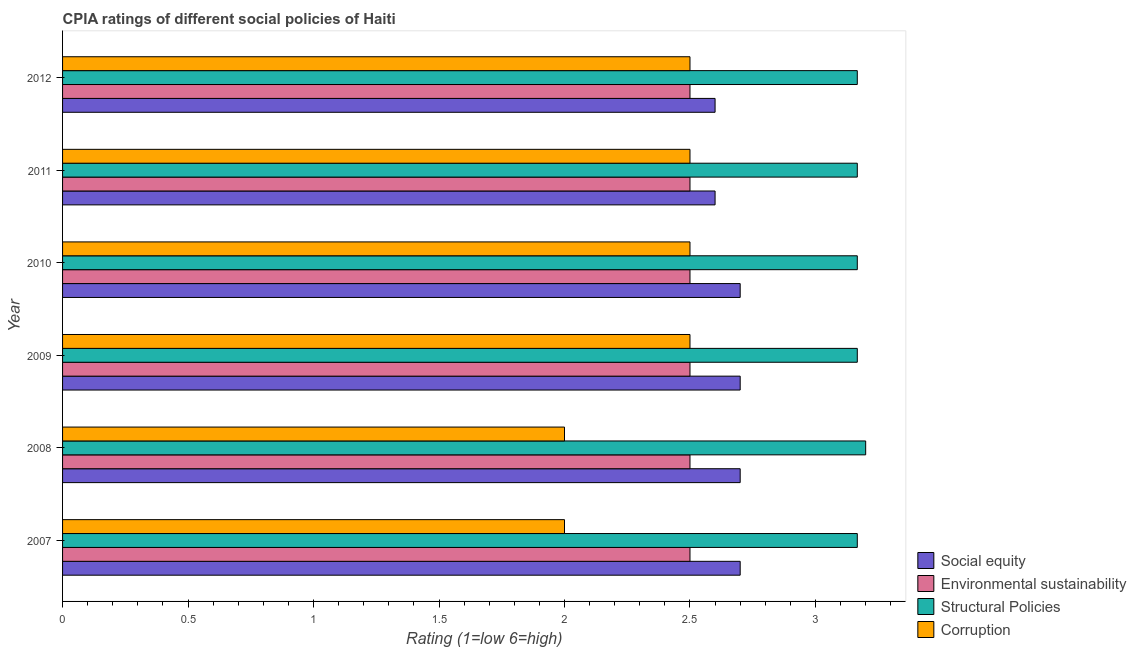Are the number of bars per tick equal to the number of legend labels?
Offer a terse response. Yes. Are the number of bars on each tick of the Y-axis equal?
Offer a very short reply. Yes. How many bars are there on the 2nd tick from the top?
Your answer should be very brief. 4. What is the label of the 5th group of bars from the top?
Offer a very short reply. 2008. Across all years, what is the maximum cpia rating of environmental sustainability?
Provide a succinct answer. 2.5. What is the difference between the cpia rating of environmental sustainability in 2007 and that in 2008?
Provide a short and direct response. 0. What is the difference between the cpia rating of social equity in 2009 and the cpia rating of corruption in 2007?
Ensure brevity in your answer.  0.7. What is the average cpia rating of structural policies per year?
Offer a very short reply. 3.17. In the year 2011, what is the difference between the cpia rating of structural policies and cpia rating of social equity?
Ensure brevity in your answer.  0.57. In how many years, is the cpia rating of structural policies greater than 1.6 ?
Provide a short and direct response. 6. What is the ratio of the cpia rating of social equity in 2009 to that in 2011?
Provide a succinct answer. 1.04. Is the cpia rating of environmental sustainability in 2007 less than that in 2012?
Provide a succinct answer. No. What is the difference between the highest and the second highest cpia rating of social equity?
Provide a short and direct response. 0. What is the difference between the highest and the lowest cpia rating of social equity?
Your response must be concise. 0.1. Is it the case that in every year, the sum of the cpia rating of structural policies and cpia rating of corruption is greater than the sum of cpia rating of environmental sustainability and cpia rating of social equity?
Give a very brief answer. No. What does the 2nd bar from the top in 2012 represents?
Offer a very short reply. Structural Policies. What does the 4th bar from the bottom in 2009 represents?
Offer a very short reply. Corruption. Is it the case that in every year, the sum of the cpia rating of social equity and cpia rating of environmental sustainability is greater than the cpia rating of structural policies?
Provide a short and direct response. Yes. How many bars are there?
Your answer should be very brief. 24. Does the graph contain any zero values?
Your response must be concise. No. Does the graph contain grids?
Ensure brevity in your answer.  No. Where does the legend appear in the graph?
Your answer should be very brief. Bottom right. What is the title of the graph?
Keep it short and to the point. CPIA ratings of different social policies of Haiti. Does "CO2 damage" appear as one of the legend labels in the graph?
Offer a terse response. No. What is the Rating (1=low 6=high) in Social equity in 2007?
Your answer should be very brief. 2.7. What is the Rating (1=low 6=high) of Environmental sustainability in 2007?
Offer a terse response. 2.5. What is the Rating (1=low 6=high) in Structural Policies in 2007?
Make the answer very short. 3.17. What is the Rating (1=low 6=high) in Corruption in 2007?
Ensure brevity in your answer.  2. What is the Rating (1=low 6=high) in Corruption in 2008?
Your answer should be very brief. 2. What is the Rating (1=low 6=high) of Social equity in 2009?
Give a very brief answer. 2.7. What is the Rating (1=low 6=high) in Structural Policies in 2009?
Keep it short and to the point. 3.17. What is the Rating (1=low 6=high) of Corruption in 2009?
Ensure brevity in your answer.  2.5. What is the Rating (1=low 6=high) of Social equity in 2010?
Give a very brief answer. 2.7. What is the Rating (1=low 6=high) of Structural Policies in 2010?
Make the answer very short. 3.17. What is the Rating (1=low 6=high) of Corruption in 2010?
Keep it short and to the point. 2.5. What is the Rating (1=low 6=high) in Structural Policies in 2011?
Offer a terse response. 3.17. What is the Rating (1=low 6=high) of Corruption in 2011?
Your response must be concise. 2.5. What is the Rating (1=low 6=high) in Social equity in 2012?
Your answer should be compact. 2.6. What is the Rating (1=low 6=high) of Environmental sustainability in 2012?
Offer a terse response. 2.5. What is the Rating (1=low 6=high) in Structural Policies in 2012?
Your answer should be compact. 3.17. What is the Rating (1=low 6=high) of Corruption in 2012?
Ensure brevity in your answer.  2.5. Across all years, what is the maximum Rating (1=low 6=high) in Structural Policies?
Ensure brevity in your answer.  3.2. Across all years, what is the maximum Rating (1=low 6=high) of Corruption?
Your answer should be compact. 2.5. Across all years, what is the minimum Rating (1=low 6=high) in Social equity?
Your answer should be very brief. 2.6. Across all years, what is the minimum Rating (1=low 6=high) of Environmental sustainability?
Provide a short and direct response. 2.5. Across all years, what is the minimum Rating (1=low 6=high) of Structural Policies?
Your answer should be compact. 3.17. Across all years, what is the minimum Rating (1=low 6=high) in Corruption?
Provide a short and direct response. 2. What is the total Rating (1=low 6=high) in Social equity in the graph?
Ensure brevity in your answer.  16. What is the total Rating (1=low 6=high) in Structural Policies in the graph?
Offer a very short reply. 19.03. What is the difference between the Rating (1=low 6=high) in Structural Policies in 2007 and that in 2008?
Your response must be concise. -0.03. What is the difference between the Rating (1=low 6=high) of Corruption in 2007 and that in 2008?
Make the answer very short. 0. What is the difference between the Rating (1=low 6=high) of Corruption in 2007 and that in 2009?
Ensure brevity in your answer.  -0.5. What is the difference between the Rating (1=low 6=high) in Social equity in 2007 and that in 2010?
Provide a short and direct response. 0. What is the difference between the Rating (1=low 6=high) of Structural Policies in 2007 and that in 2010?
Your answer should be very brief. 0. What is the difference between the Rating (1=low 6=high) of Environmental sustainability in 2007 and that in 2011?
Offer a terse response. 0. What is the difference between the Rating (1=low 6=high) of Structural Policies in 2007 and that in 2011?
Make the answer very short. 0. What is the difference between the Rating (1=low 6=high) of Environmental sustainability in 2008 and that in 2009?
Provide a short and direct response. 0. What is the difference between the Rating (1=low 6=high) of Structural Policies in 2008 and that in 2010?
Offer a terse response. 0.03. What is the difference between the Rating (1=low 6=high) in Corruption in 2008 and that in 2010?
Provide a succinct answer. -0.5. What is the difference between the Rating (1=low 6=high) of Social equity in 2009 and that in 2010?
Make the answer very short. 0. What is the difference between the Rating (1=low 6=high) in Environmental sustainability in 2009 and that in 2010?
Give a very brief answer. 0. What is the difference between the Rating (1=low 6=high) of Structural Policies in 2009 and that in 2010?
Keep it short and to the point. 0. What is the difference between the Rating (1=low 6=high) of Corruption in 2009 and that in 2010?
Offer a very short reply. 0. What is the difference between the Rating (1=low 6=high) of Environmental sustainability in 2010 and that in 2011?
Offer a terse response. 0. What is the difference between the Rating (1=low 6=high) of Environmental sustainability in 2010 and that in 2012?
Give a very brief answer. 0. What is the difference between the Rating (1=low 6=high) in Structural Policies in 2010 and that in 2012?
Give a very brief answer. 0. What is the difference between the Rating (1=low 6=high) in Corruption in 2010 and that in 2012?
Make the answer very short. 0. What is the difference between the Rating (1=low 6=high) of Corruption in 2011 and that in 2012?
Keep it short and to the point. 0. What is the difference between the Rating (1=low 6=high) in Social equity in 2007 and the Rating (1=low 6=high) in Structural Policies in 2008?
Your answer should be compact. -0.5. What is the difference between the Rating (1=low 6=high) in Social equity in 2007 and the Rating (1=low 6=high) in Corruption in 2008?
Offer a terse response. 0.7. What is the difference between the Rating (1=low 6=high) of Environmental sustainability in 2007 and the Rating (1=low 6=high) of Structural Policies in 2008?
Provide a short and direct response. -0.7. What is the difference between the Rating (1=low 6=high) of Environmental sustainability in 2007 and the Rating (1=low 6=high) of Corruption in 2008?
Offer a very short reply. 0.5. What is the difference between the Rating (1=low 6=high) in Social equity in 2007 and the Rating (1=low 6=high) in Structural Policies in 2009?
Give a very brief answer. -0.47. What is the difference between the Rating (1=low 6=high) in Environmental sustainability in 2007 and the Rating (1=low 6=high) in Structural Policies in 2009?
Provide a succinct answer. -0.67. What is the difference between the Rating (1=low 6=high) of Structural Policies in 2007 and the Rating (1=low 6=high) of Corruption in 2009?
Ensure brevity in your answer.  0.67. What is the difference between the Rating (1=low 6=high) in Social equity in 2007 and the Rating (1=low 6=high) in Environmental sustainability in 2010?
Make the answer very short. 0.2. What is the difference between the Rating (1=low 6=high) of Social equity in 2007 and the Rating (1=low 6=high) of Structural Policies in 2010?
Your answer should be very brief. -0.47. What is the difference between the Rating (1=low 6=high) in Environmental sustainability in 2007 and the Rating (1=low 6=high) in Corruption in 2010?
Offer a very short reply. 0. What is the difference between the Rating (1=low 6=high) in Social equity in 2007 and the Rating (1=low 6=high) in Structural Policies in 2011?
Provide a succinct answer. -0.47. What is the difference between the Rating (1=low 6=high) of Environmental sustainability in 2007 and the Rating (1=low 6=high) of Structural Policies in 2011?
Provide a succinct answer. -0.67. What is the difference between the Rating (1=low 6=high) of Social equity in 2007 and the Rating (1=low 6=high) of Structural Policies in 2012?
Ensure brevity in your answer.  -0.47. What is the difference between the Rating (1=low 6=high) of Environmental sustainability in 2007 and the Rating (1=low 6=high) of Corruption in 2012?
Give a very brief answer. 0. What is the difference between the Rating (1=low 6=high) of Structural Policies in 2007 and the Rating (1=low 6=high) of Corruption in 2012?
Provide a short and direct response. 0.67. What is the difference between the Rating (1=low 6=high) of Social equity in 2008 and the Rating (1=low 6=high) of Environmental sustainability in 2009?
Your answer should be very brief. 0.2. What is the difference between the Rating (1=low 6=high) of Social equity in 2008 and the Rating (1=low 6=high) of Structural Policies in 2009?
Offer a very short reply. -0.47. What is the difference between the Rating (1=low 6=high) in Structural Policies in 2008 and the Rating (1=low 6=high) in Corruption in 2009?
Provide a succinct answer. 0.7. What is the difference between the Rating (1=low 6=high) of Social equity in 2008 and the Rating (1=low 6=high) of Environmental sustainability in 2010?
Offer a terse response. 0.2. What is the difference between the Rating (1=low 6=high) in Social equity in 2008 and the Rating (1=low 6=high) in Structural Policies in 2010?
Ensure brevity in your answer.  -0.47. What is the difference between the Rating (1=low 6=high) of Social equity in 2008 and the Rating (1=low 6=high) of Corruption in 2010?
Offer a very short reply. 0.2. What is the difference between the Rating (1=low 6=high) of Environmental sustainability in 2008 and the Rating (1=low 6=high) of Corruption in 2010?
Ensure brevity in your answer.  0. What is the difference between the Rating (1=low 6=high) in Social equity in 2008 and the Rating (1=low 6=high) in Environmental sustainability in 2011?
Your answer should be compact. 0.2. What is the difference between the Rating (1=low 6=high) of Social equity in 2008 and the Rating (1=low 6=high) of Structural Policies in 2011?
Ensure brevity in your answer.  -0.47. What is the difference between the Rating (1=low 6=high) of Social equity in 2008 and the Rating (1=low 6=high) of Corruption in 2011?
Your answer should be very brief. 0.2. What is the difference between the Rating (1=low 6=high) in Environmental sustainability in 2008 and the Rating (1=low 6=high) in Corruption in 2011?
Offer a terse response. 0. What is the difference between the Rating (1=low 6=high) of Social equity in 2008 and the Rating (1=low 6=high) of Structural Policies in 2012?
Give a very brief answer. -0.47. What is the difference between the Rating (1=low 6=high) of Social equity in 2008 and the Rating (1=low 6=high) of Corruption in 2012?
Give a very brief answer. 0.2. What is the difference between the Rating (1=low 6=high) in Environmental sustainability in 2008 and the Rating (1=low 6=high) in Structural Policies in 2012?
Offer a terse response. -0.67. What is the difference between the Rating (1=low 6=high) in Environmental sustainability in 2008 and the Rating (1=low 6=high) in Corruption in 2012?
Your answer should be very brief. 0. What is the difference between the Rating (1=low 6=high) of Social equity in 2009 and the Rating (1=low 6=high) of Structural Policies in 2010?
Your answer should be very brief. -0.47. What is the difference between the Rating (1=low 6=high) of Social equity in 2009 and the Rating (1=low 6=high) of Corruption in 2010?
Your answer should be compact. 0.2. What is the difference between the Rating (1=low 6=high) of Environmental sustainability in 2009 and the Rating (1=low 6=high) of Corruption in 2010?
Offer a terse response. 0. What is the difference between the Rating (1=low 6=high) in Social equity in 2009 and the Rating (1=low 6=high) in Structural Policies in 2011?
Provide a short and direct response. -0.47. What is the difference between the Rating (1=low 6=high) of Social equity in 2009 and the Rating (1=low 6=high) of Corruption in 2011?
Give a very brief answer. 0.2. What is the difference between the Rating (1=low 6=high) of Structural Policies in 2009 and the Rating (1=low 6=high) of Corruption in 2011?
Make the answer very short. 0.67. What is the difference between the Rating (1=low 6=high) in Social equity in 2009 and the Rating (1=low 6=high) in Structural Policies in 2012?
Offer a very short reply. -0.47. What is the difference between the Rating (1=low 6=high) of Environmental sustainability in 2009 and the Rating (1=low 6=high) of Structural Policies in 2012?
Provide a succinct answer. -0.67. What is the difference between the Rating (1=low 6=high) in Structural Policies in 2009 and the Rating (1=low 6=high) in Corruption in 2012?
Give a very brief answer. 0.67. What is the difference between the Rating (1=low 6=high) in Social equity in 2010 and the Rating (1=low 6=high) in Structural Policies in 2011?
Make the answer very short. -0.47. What is the difference between the Rating (1=low 6=high) of Social equity in 2010 and the Rating (1=low 6=high) of Corruption in 2011?
Provide a succinct answer. 0.2. What is the difference between the Rating (1=low 6=high) of Environmental sustainability in 2010 and the Rating (1=low 6=high) of Structural Policies in 2011?
Make the answer very short. -0.67. What is the difference between the Rating (1=low 6=high) of Structural Policies in 2010 and the Rating (1=low 6=high) of Corruption in 2011?
Provide a succinct answer. 0.67. What is the difference between the Rating (1=low 6=high) in Social equity in 2010 and the Rating (1=low 6=high) in Structural Policies in 2012?
Offer a very short reply. -0.47. What is the difference between the Rating (1=low 6=high) in Social equity in 2010 and the Rating (1=low 6=high) in Corruption in 2012?
Your answer should be very brief. 0.2. What is the difference between the Rating (1=low 6=high) in Environmental sustainability in 2010 and the Rating (1=low 6=high) in Structural Policies in 2012?
Provide a short and direct response. -0.67. What is the difference between the Rating (1=low 6=high) of Environmental sustainability in 2010 and the Rating (1=low 6=high) of Corruption in 2012?
Give a very brief answer. 0. What is the difference between the Rating (1=low 6=high) of Social equity in 2011 and the Rating (1=low 6=high) of Structural Policies in 2012?
Your answer should be very brief. -0.57. What is the difference between the Rating (1=low 6=high) of Social equity in 2011 and the Rating (1=low 6=high) of Corruption in 2012?
Make the answer very short. 0.1. What is the difference between the Rating (1=low 6=high) in Environmental sustainability in 2011 and the Rating (1=low 6=high) in Corruption in 2012?
Keep it short and to the point. 0. What is the average Rating (1=low 6=high) in Social equity per year?
Offer a terse response. 2.67. What is the average Rating (1=low 6=high) in Environmental sustainability per year?
Provide a succinct answer. 2.5. What is the average Rating (1=low 6=high) of Structural Policies per year?
Your answer should be very brief. 3.17. What is the average Rating (1=low 6=high) in Corruption per year?
Make the answer very short. 2.33. In the year 2007, what is the difference between the Rating (1=low 6=high) in Social equity and Rating (1=low 6=high) in Environmental sustainability?
Provide a short and direct response. 0.2. In the year 2007, what is the difference between the Rating (1=low 6=high) of Social equity and Rating (1=low 6=high) of Structural Policies?
Keep it short and to the point. -0.47. In the year 2007, what is the difference between the Rating (1=low 6=high) in Social equity and Rating (1=low 6=high) in Corruption?
Ensure brevity in your answer.  0.7. In the year 2007, what is the difference between the Rating (1=low 6=high) of Environmental sustainability and Rating (1=low 6=high) of Corruption?
Ensure brevity in your answer.  0.5. In the year 2008, what is the difference between the Rating (1=low 6=high) in Social equity and Rating (1=low 6=high) in Environmental sustainability?
Your answer should be compact. 0.2. In the year 2008, what is the difference between the Rating (1=low 6=high) in Social equity and Rating (1=low 6=high) in Structural Policies?
Your response must be concise. -0.5. In the year 2008, what is the difference between the Rating (1=low 6=high) in Social equity and Rating (1=low 6=high) in Corruption?
Keep it short and to the point. 0.7. In the year 2008, what is the difference between the Rating (1=low 6=high) in Environmental sustainability and Rating (1=low 6=high) in Structural Policies?
Your answer should be very brief. -0.7. In the year 2008, what is the difference between the Rating (1=low 6=high) in Structural Policies and Rating (1=low 6=high) in Corruption?
Give a very brief answer. 1.2. In the year 2009, what is the difference between the Rating (1=low 6=high) of Social equity and Rating (1=low 6=high) of Environmental sustainability?
Your response must be concise. 0.2. In the year 2009, what is the difference between the Rating (1=low 6=high) in Social equity and Rating (1=low 6=high) in Structural Policies?
Ensure brevity in your answer.  -0.47. In the year 2009, what is the difference between the Rating (1=low 6=high) of Environmental sustainability and Rating (1=low 6=high) of Structural Policies?
Your answer should be very brief. -0.67. In the year 2009, what is the difference between the Rating (1=low 6=high) of Environmental sustainability and Rating (1=low 6=high) of Corruption?
Make the answer very short. 0. In the year 2010, what is the difference between the Rating (1=low 6=high) of Social equity and Rating (1=low 6=high) of Environmental sustainability?
Ensure brevity in your answer.  0.2. In the year 2010, what is the difference between the Rating (1=low 6=high) of Social equity and Rating (1=low 6=high) of Structural Policies?
Give a very brief answer. -0.47. In the year 2010, what is the difference between the Rating (1=low 6=high) in Social equity and Rating (1=low 6=high) in Corruption?
Your answer should be compact. 0.2. In the year 2010, what is the difference between the Rating (1=low 6=high) in Environmental sustainability and Rating (1=low 6=high) in Structural Policies?
Provide a succinct answer. -0.67. In the year 2010, what is the difference between the Rating (1=low 6=high) in Environmental sustainability and Rating (1=low 6=high) in Corruption?
Keep it short and to the point. 0. In the year 2011, what is the difference between the Rating (1=low 6=high) of Social equity and Rating (1=low 6=high) of Environmental sustainability?
Offer a very short reply. 0.1. In the year 2011, what is the difference between the Rating (1=low 6=high) in Social equity and Rating (1=low 6=high) in Structural Policies?
Provide a short and direct response. -0.57. In the year 2011, what is the difference between the Rating (1=low 6=high) of Environmental sustainability and Rating (1=low 6=high) of Structural Policies?
Make the answer very short. -0.67. In the year 2011, what is the difference between the Rating (1=low 6=high) in Environmental sustainability and Rating (1=low 6=high) in Corruption?
Your answer should be very brief. 0. In the year 2011, what is the difference between the Rating (1=low 6=high) of Structural Policies and Rating (1=low 6=high) of Corruption?
Offer a very short reply. 0.67. In the year 2012, what is the difference between the Rating (1=low 6=high) of Social equity and Rating (1=low 6=high) of Environmental sustainability?
Offer a terse response. 0.1. In the year 2012, what is the difference between the Rating (1=low 6=high) in Social equity and Rating (1=low 6=high) in Structural Policies?
Provide a succinct answer. -0.57. In the year 2012, what is the difference between the Rating (1=low 6=high) in Environmental sustainability and Rating (1=low 6=high) in Structural Policies?
Ensure brevity in your answer.  -0.67. In the year 2012, what is the difference between the Rating (1=low 6=high) of Environmental sustainability and Rating (1=low 6=high) of Corruption?
Keep it short and to the point. 0. What is the ratio of the Rating (1=low 6=high) of Social equity in 2007 to that in 2008?
Provide a succinct answer. 1. What is the ratio of the Rating (1=low 6=high) in Structural Policies in 2007 to that in 2008?
Provide a short and direct response. 0.99. What is the ratio of the Rating (1=low 6=high) of Environmental sustainability in 2007 to that in 2009?
Provide a succinct answer. 1. What is the ratio of the Rating (1=low 6=high) in Structural Policies in 2007 to that in 2009?
Offer a very short reply. 1. What is the ratio of the Rating (1=low 6=high) of Corruption in 2007 to that in 2009?
Make the answer very short. 0.8. What is the ratio of the Rating (1=low 6=high) in Social equity in 2007 to that in 2012?
Keep it short and to the point. 1.04. What is the ratio of the Rating (1=low 6=high) of Structural Policies in 2008 to that in 2009?
Provide a succinct answer. 1.01. What is the ratio of the Rating (1=low 6=high) of Corruption in 2008 to that in 2009?
Your response must be concise. 0.8. What is the ratio of the Rating (1=low 6=high) of Social equity in 2008 to that in 2010?
Offer a terse response. 1. What is the ratio of the Rating (1=low 6=high) in Environmental sustainability in 2008 to that in 2010?
Your answer should be compact. 1. What is the ratio of the Rating (1=low 6=high) in Structural Policies in 2008 to that in 2010?
Your answer should be very brief. 1.01. What is the ratio of the Rating (1=low 6=high) in Corruption in 2008 to that in 2010?
Your answer should be very brief. 0.8. What is the ratio of the Rating (1=low 6=high) of Social equity in 2008 to that in 2011?
Give a very brief answer. 1.04. What is the ratio of the Rating (1=low 6=high) of Environmental sustainability in 2008 to that in 2011?
Your answer should be compact. 1. What is the ratio of the Rating (1=low 6=high) in Structural Policies in 2008 to that in 2011?
Give a very brief answer. 1.01. What is the ratio of the Rating (1=low 6=high) in Corruption in 2008 to that in 2011?
Your response must be concise. 0.8. What is the ratio of the Rating (1=low 6=high) in Social equity in 2008 to that in 2012?
Offer a terse response. 1.04. What is the ratio of the Rating (1=low 6=high) of Environmental sustainability in 2008 to that in 2012?
Your response must be concise. 1. What is the ratio of the Rating (1=low 6=high) of Structural Policies in 2008 to that in 2012?
Provide a short and direct response. 1.01. What is the ratio of the Rating (1=low 6=high) of Corruption in 2008 to that in 2012?
Your response must be concise. 0.8. What is the ratio of the Rating (1=low 6=high) of Structural Policies in 2009 to that in 2010?
Your response must be concise. 1. What is the ratio of the Rating (1=low 6=high) of Corruption in 2009 to that in 2010?
Offer a very short reply. 1. What is the ratio of the Rating (1=low 6=high) in Social equity in 2009 to that in 2011?
Provide a succinct answer. 1.04. What is the ratio of the Rating (1=low 6=high) of Environmental sustainability in 2009 to that in 2011?
Your answer should be very brief. 1. What is the ratio of the Rating (1=low 6=high) of Structural Policies in 2009 to that in 2011?
Keep it short and to the point. 1. What is the ratio of the Rating (1=low 6=high) in Social equity in 2009 to that in 2012?
Make the answer very short. 1.04. What is the ratio of the Rating (1=low 6=high) of Environmental sustainability in 2009 to that in 2012?
Offer a terse response. 1. What is the ratio of the Rating (1=low 6=high) in Corruption in 2009 to that in 2012?
Keep it short and to the point. 1. What is the ratio of the Rating (1=low 6=high) in Corruption in 2010 to that in 2011?
Ensure brevity in your answer.  1. What is the ratio of the Rating (1=low 6=high) of Environmental sustainability in 2010 to that in 2012?
Give a very brief answer. 1. What is the ratio of the Rating (1=low 6=high) in Structural Policies in 2010 to that in 2012?
Your response must be concise. 1. What is the ratio of the Rating (1=low 6=high) of Corruption in 2010 to that in 2012?
Offer a terse response. 1. What is the ratio of the Rating (1=low 6=high) in Social equity in 2011 to that in 2012?
Your response must be concise. 1. What is the ratio of the Rating (1=low 6=high) in Environmental sustainability in 2011 to that in 2012?
Ensure brevity in your answer.  1. What is the ratio of the Rating (1=low 6=high) in Structural Policies in 2011 to that in 2012?
Provide a succinct answer. 1. What is the ratio of the Rating (1=low 6=high) of Corruption in 2011 to that in 2012?
Provide a succinct answer. 1. What is the difference between the highest and the second highest Rating (1=low 6=high) of Social equity?
Make the answer very short. 0. 